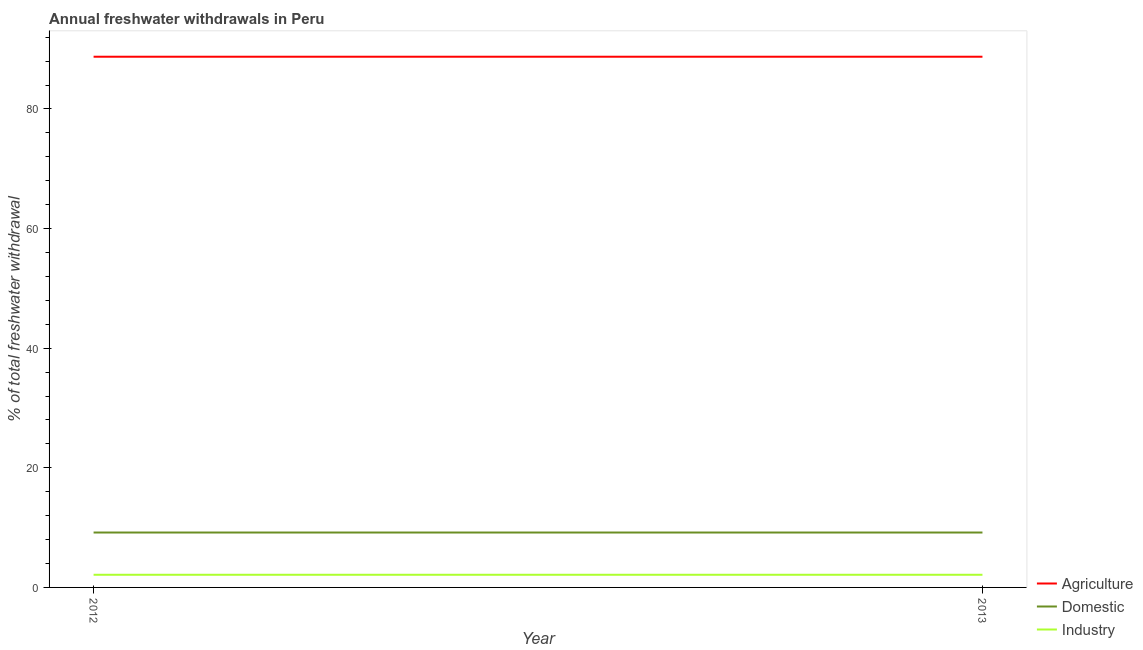Does the line corresponding to percentage of freshwater withdrawal for domestic purposes intersect with the line corresponding to percentage of freshwater withdrawal for agriculture?
Keep it short and to the point. No. Is the number of lines equal to the number of legend labels?
Your response must be concise. Yes. What is the percentage of freshwater withdrawal for domestic purposes in 2013?
Offer a very short reply. 9.18. Across all years, what is the maximum percentage of freshwater withdrawal for domestic purposes?
Make the answer very short. 9.18. Across all years, what is the minimum percentage of freshwater withdrawal for domestic purposes?
Ensure brevity in your answer.  9.18. In which year was the percentage of freshwater withdrawal for domestic purposes minimum?
Ensure brevity in your answer.  2012. What is the total percentage of freshwater withdrawal for agriculture in the graph?
Ensure brevity in your answer.  177.46. What is the difference between the percentage of freshwater withdrawal for industry in 2013 and the percentage of freshwater withdrawal for domestic purposes in 2012?
Ensure brevity in your answer.  -7.06. What is the average percentage of freshwater withdrawal for agriculture per year?
Offer a very short reply. 88.73. In the year 2012, what is the difference between the percentage of freshwater withdrawal for agriculture and percentage of freshwater withdrawal for industry?
Your answer should be very brief. 86.61. What is the ratio of the percentage of freshwater withdrawal for agriculture in 2012 to that in 2013?
Your answer should be very brief. 1. In how many years, is the percentage of freshwater withdrawal for industry greater than the average percentage of freshwater withdrawal for industry taken over all years?
Keep it short and to the point. 0. Is it the case that in every year, the sum of the percentage of freshwater withdrawal for agriculture and percentage of freshwater withdrawal for domestic purposes is greater than the percentage of freshwater withdrawal for industry?
Offer a terse response. Yes. Does the percentage of freshwater withdrawal for agriculture monotonically increase over the years?
Offer a very short reply. No. Is the percentage of freshwater withdrawal for industry strictly greater than the percentage of freshwater withdrawal for agriculture over the years?
Give a very brief answer. No. How many lines are there?
Provide a short and direct response. 3. How are the legend labels stacked?
Your response must be concise. Vertical. What is the title of the graph?
Provide a short and direct response. Annual freshwater withdrawals in Peru. Does "Natural gas sources" appear as one of the legend labels in the graph?
Keep it short and to the point. No. What is the label or title of the Y-axis?
Ensure brevity in your answer.  % of total freshwater withdrawal. What is the % of total freshwater withdrawal in Agriculture in 2012?
Offer a very short reply. 88.73. What is the % of total freshwater withdrawal of Domestic in 2012?
Make the answer very short. 9.18. What is the % of total freshwater withdrawal of Industry in 2012?
Make the answer very short. 2.12. What is the % of total freshwater withdrawal in Agriculture in 2013?
Your answer should be compact. 88.73. What is the % of total freshwater withdrawal in Domestic in 2013?
Your answer should be compact. 9.18. What is the % of total freshwater withdrawal in Industry in 2013?
Provide a short and direct response. 2.12. Across all years, what is the maximum % of total freshwater withdrawal in Agriculture?
Your answer should be compact. 88.73. Across all years, what is the maximum % of total freshwater withdrawal in Domestic?
Offer a very short reply. 9.18. Across all years, what is the maximum % of total freshwater withdrawal in Industry?
Keep it short and to the point. 2.12. Across all years, what is the minimum % of total freshwater withdrawal in Agriculture?
Your answer should be very brief. 88.73. Across all years, what is the minimum % of total freshwater withdrawal of Domestic?
Your response must be concise. 9.18. Across all years, what is the minimum % of total freshwater withdrawal of Industry?
Keep it short and to the point. 2.12. What is the total % of total freshwater withdrawal in Agriculture in the graph?
Offer a very short reply. 177.46. What is the total % of total freshwater withdrawal in Domestic in the graph?
Give a very brief answer. 18.36. What is the total % of total freshwater withdrawal in Industry in the graph?
Give a very brief answer. 4.23. What is the difference between the % of total freshwater withdrawal of Industry in 2012 and that in 2013?
Ensure brevity in your answer.  0. What is the difference between the % of total freshwater withdrawal of Agriculture in 2012 and the % of total freshwater withdrawal of Domestic in 2013?
Your answer should be compact. 79.55. What is the difference between the % of total freshwater withdrawal of Agriculture in 2012 and the % of total freshwater withdrawal of Industry in 2013?
Your answer should be compact. 86.61. What is the difference between the % of total freshwater withdrawal of Domestic in 2012 and the % of total freshwater withdrawal of Industry in 2013?
Your answer should be very brief. 7.06. What is the average % of total freshwater withdrawal in Agriculture per year?
Keep it short and to the point. 88.73. What is the average % of total freshwater withdrawal of Domestic per year?
Your response must be concise. 9.18. What is the average % of total freshwater withdrawal of Industry per year?
Ensure brevity in your answer.  2.12. In the year 2012, what is the difference between the % of total freshwater withdrawal in Agriculture and % of total freshwater withdrawal in Domestic?
Provide a short and direct response. 79.55. In the year 2012, what is the difference between the % of total freshwater withdrawal in Agriculture and % of total freshwater withdrawal in Industry?
Your response must be concise. 86.61. In the year 2012, what is the difference between the % of total freshwater withdrawal in Domestic and % of total freshwater withdrawal in Industry?
Your response must be concise. 7.06. In the year 2013, what is the difference between the % of total freshwater withdrawal in Agriculture and % of total freshwater withdrawal in Domestic?
Offer a very short reply. 79.55. In the year 2013, what is the difference between the % of total freshwater withdrawal of Agriculture and % of total freshwater withdrawal of Industry?
Ensure brevity in your answer.  86.61. In the year 2013, what is the difference between the % of total freshwater withdrawal in Domestic and % of total freshwater withdrawal in Industry?
Ensure brevity in your answer.  7.06. What is the ratio of the % of total freshwater withdrawal of Agriculture in 2012 to that in 2013?
Offer a terse response. 1. What is the ratio of the % of total freshwater withdrawal of Domestic in 2012 to that in 2013?
Offer a terse response. 1. What is the ratio of the % of total freshwater withdrawal of Industry in 2012 to that in 2013?
Your answer should be compact. 1. What is the difference between the highest and the second highest % of total freshwater withdrawal of Industry?
Your answer should be compact. 0. What is the difference between the highest and the lowest % of total freshwater withdrawal of Domestic?
Your answer should be compact. 0. What is the difference between the highest and the lowest % of total freshwater withdrawal in Industry?
Your answer should be very brief. 0. 